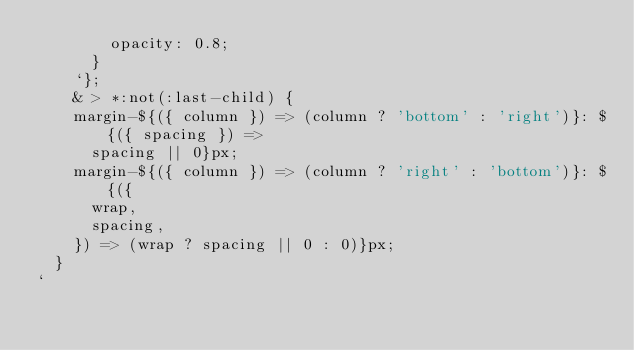Convert code to text. <code><loc_0><loc_0><loc_500><loc_500><_JavaScript_>        opacity: 0.8;
      }
    `};
    & > *:not(:last-child) {
    margin-${({ column }) => (column ? 'bottom' : 'right')}: ${({ spacing }) =>
      spacing || 0}px;
    margin-${({ column }) => (column ? 'right' : 'bottom')}: ${({
      wrap,
      spacing,
    }) => (wrap ? spacing || 0 : 0)}px;
  }
`
</code> 